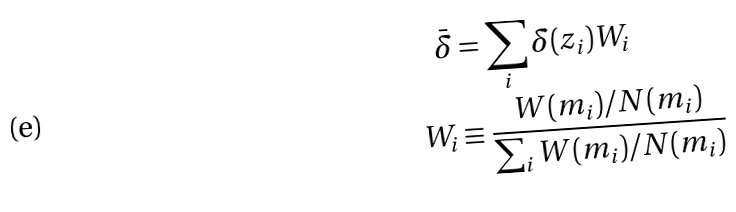<formula> <loc_0><loc_0><loc_500><loc_500>\bar { \delta } & = \sum _ { i } \delta ( z _ { i } ) W _ { i } \\ W _ { i } & \equiv \frac { W ( m _ { i } ) / N ( m _ { i } ) } { \sum _ { i } W ( m _ { i } ) / N ( m _ { i } ) }</formula> 